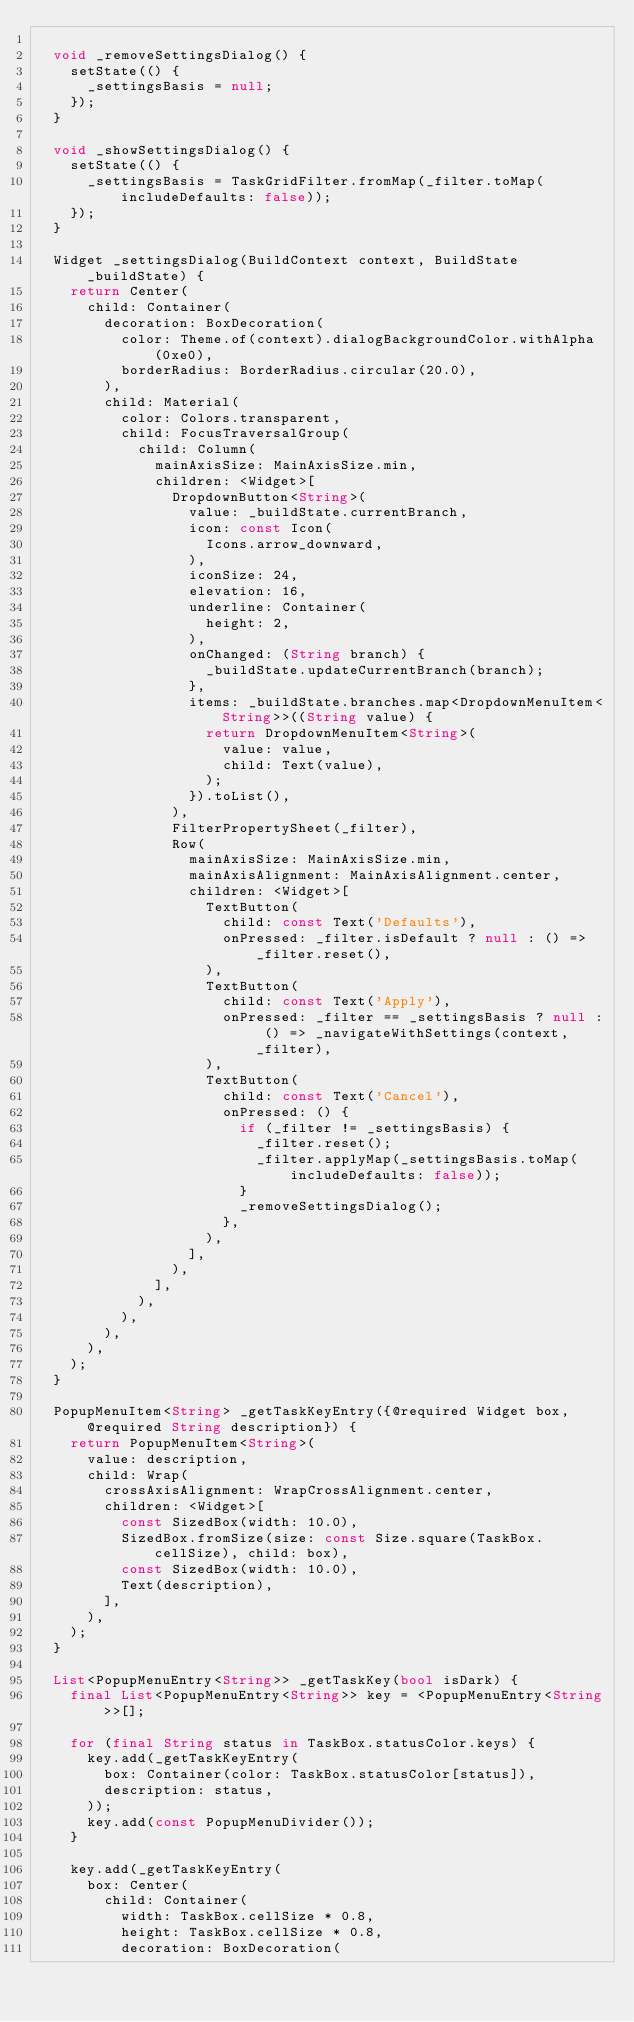<code> <loc_0><loc_0><loc_500><loc_500><_Dart_>
  void _removeSettingsDialog() {
    setState(() {
      _settingsBasis = null;
    });
  }

  void _showSettingsDialog() {
    setState(() {
      _settingsBasis = TaskGridFilter.fromMap(_filter.toMap(includeDefaults: false));
    });
  }

  Widget _settingsDialog(BuildContext context, BuildState _buildState) {
    return Center(
      child: Container(
        decoration: BoxDecoration(
          color: Theme.of(context).dialogBackgroundColor.withAlpha(0xe0),
          borderRadius: BorderRadius.circular(20.0),
        ),
        child: Material(
          color: Colors.transparent,
          child: FocusTraversalGroup(
            child: Column(
              mainAxisSize: MainAxisSize.min,
              children: <Widget>[
                DropdownButton<String>(
                  value: _buildState.currentBranch,
                  icon: const Icon(
                    Icons.arrow_downward,
                  ),
                  iconSize: 24,
                  elevation: 16,
                  underline: Container(
                    height: 2,
                  ),
                  onChanged: (String branch) {
                    _buildState.updateCurrentBranch(branch);
                  },
                  items: _buildState.branches.map<DropdownMenuItem<String>>((String value) {
                    return DropdownMenuItem<String>(
                      value: value,
                      child: Text(value),
                    );
                  }).toList(),
                ),
                FilterPropertySheet(_filter),
                Row(
                  mainAxisSize: MainAxisSize.min,
                  mainAxisAlignment: MainAxisAlignment.center,
                  children: <Widget>[
                    TextButton(
                      child: const Text('Defaults'),
                      onPressed: _filter.isDefault ? null : () => _filter.reset(),
                    ),
                    TextButton(
                      child: const Text('Apply'),
                      onPressed: _filter == _settingsBasis ? null : () => _navigateWithSettings(context, _filter),
                    ),
                    TextButton(
                      child: const Text('Cancel'),
                      onPressed: () {
                        if (_filter != _settingsBasis) {
                          _filter.reset();
                          _filter.applyMap(_settingsBasis.toMap(includeDefaults: false));
                        }
                        _removeSettingsDialog();
                      },
                    ),
                  ],
                ),
              ],
            ),
          ),
        ),
      ),
    );
  }

  PopupMenuItem<String> _getTaskKeyEntry({@required Widget box, @required String description}) {
    return PopupMenuItem<String>(
      value: description,
      child: Wrap(
        crossAxisAlignment: WrapCrossAlignment.center,
        children: <Widget>[
          const SizedBox(width: 10.0),
          SizedBox.fromSize(size: const Size.square(TaskBox.cellSize), child: box),
          const SizedBox(width: 10.0),
          Text(description),
        ],
      ),
    );
  }

  List<PopupMenuEntry<String>> _getTaskKey(bool isDark) {
    final List<PopupMenuEntry<String>> key = <PopupMenuEntry<String>>[];

    for (final String status in TaskBox.statusColor.keys) {
      key.add(_getTaskKeyEntry(
        box: Container(color: TaskBox.statusColor[status]),
        description: status,
      ));
      key.add(const PopupMenuDivider());
    }

    key.add(_getTaskKeyEntry(
      box: Center(
        child: Container(
          width: TaskBox.cellSize * 0.8,
          height: TaskBox.cellSize * 0.8,
          decoration: BoxDecoration(</code> 